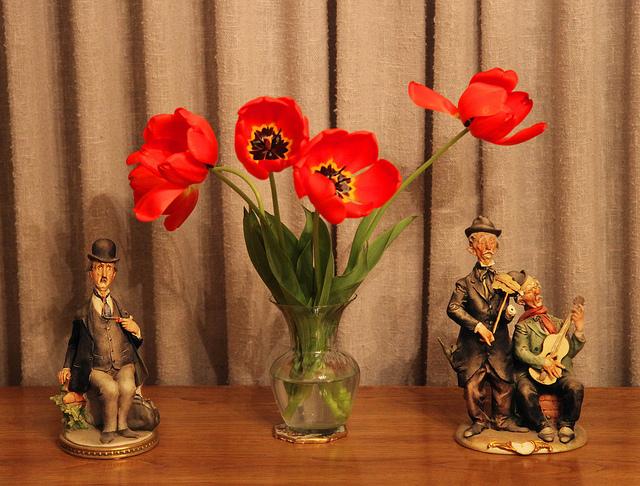What color are the poppies?
Give a very brief answer. Red. Are these quaint?
Answer briefly. Yes. What is the object the flowers are in called?
Be succinct. Vase. 